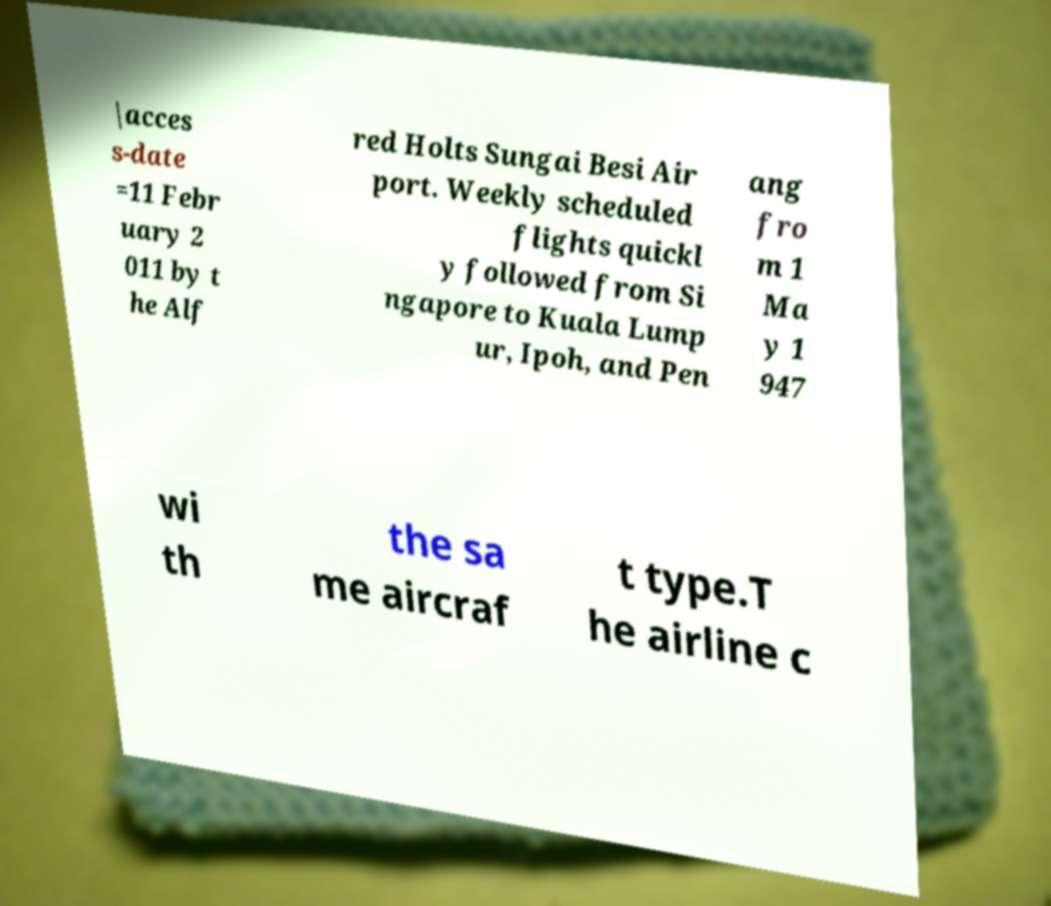What messages or text are displayed in this image? I need them in a readable, typed format. |acces s-date =11 Febr uary 2 011 by t he Alf red Holts Sungai Besi Air port. Weekly scheduled flights quickl y followed from Si ngapore to Kuala Lump ur, Ipoh, and Pen ang fro m 1 Ma y 1 947 wi th the sa me aircraf t type.T he airline c 